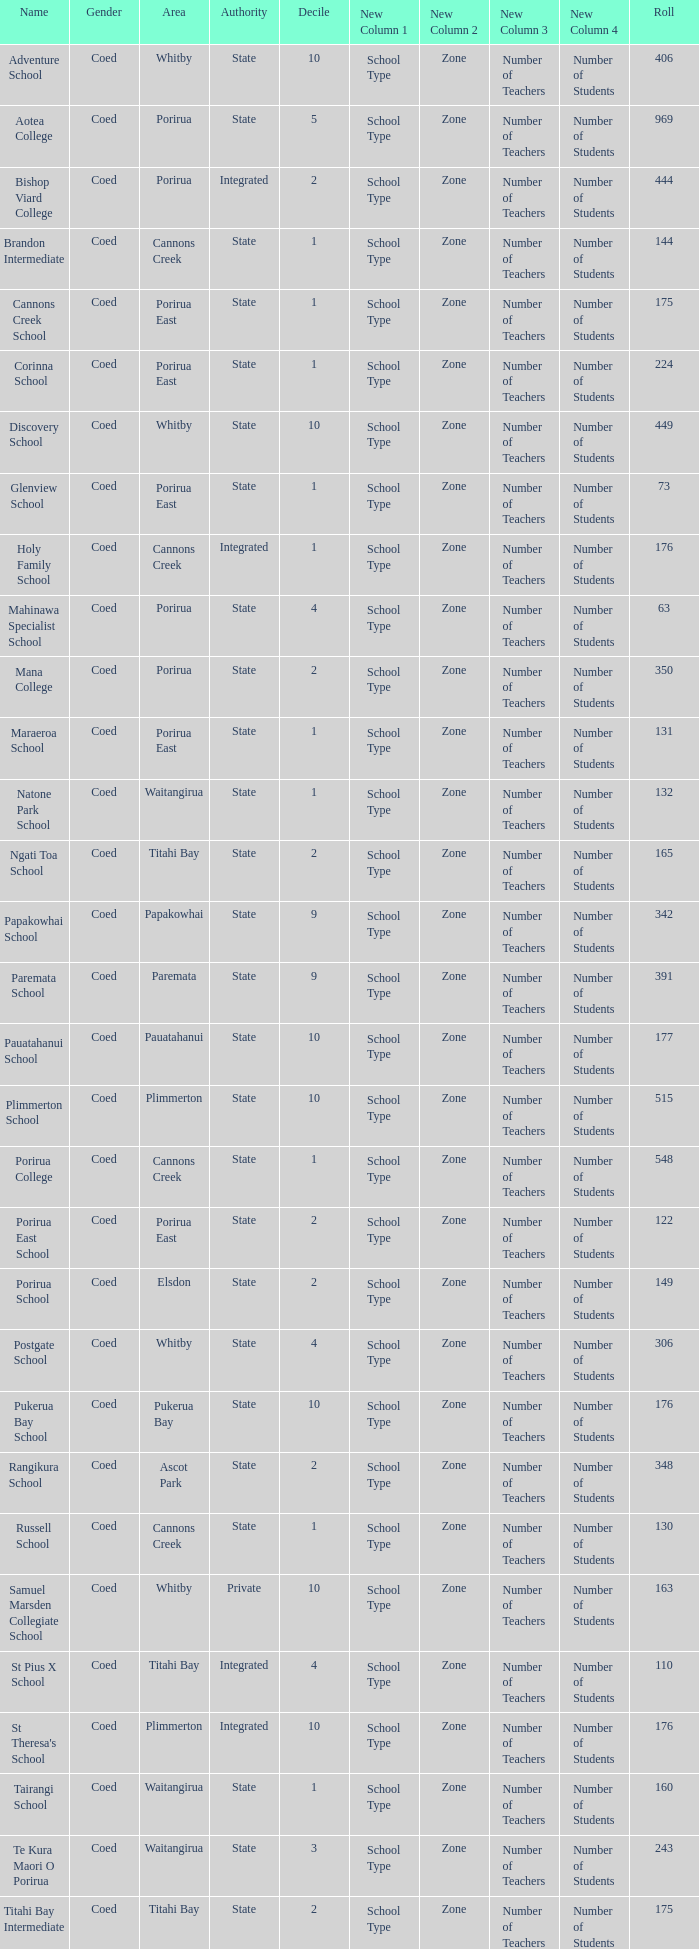What was the decile of Samuel Marsden Collegiate School in Whitby, when it had a roll higher than 163? 0.0. 